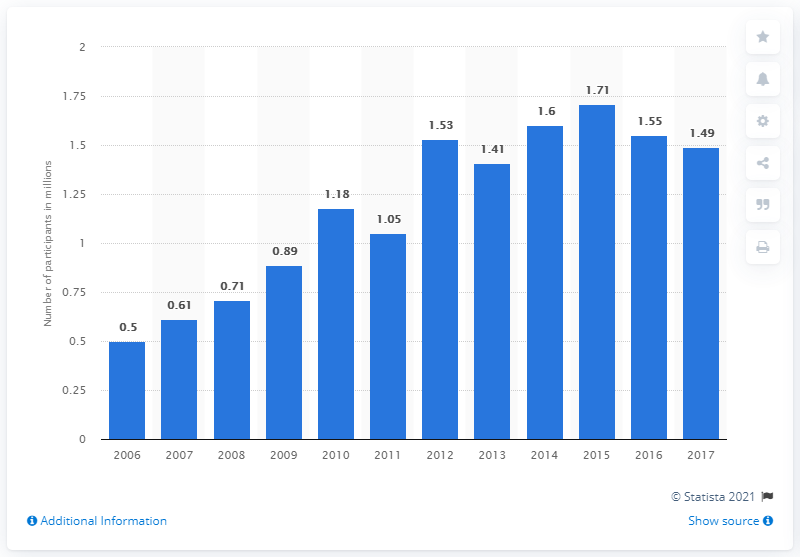Specify some key components in this picture. In 2017, the total number of participants in squash in the United States was 1,490,000. 